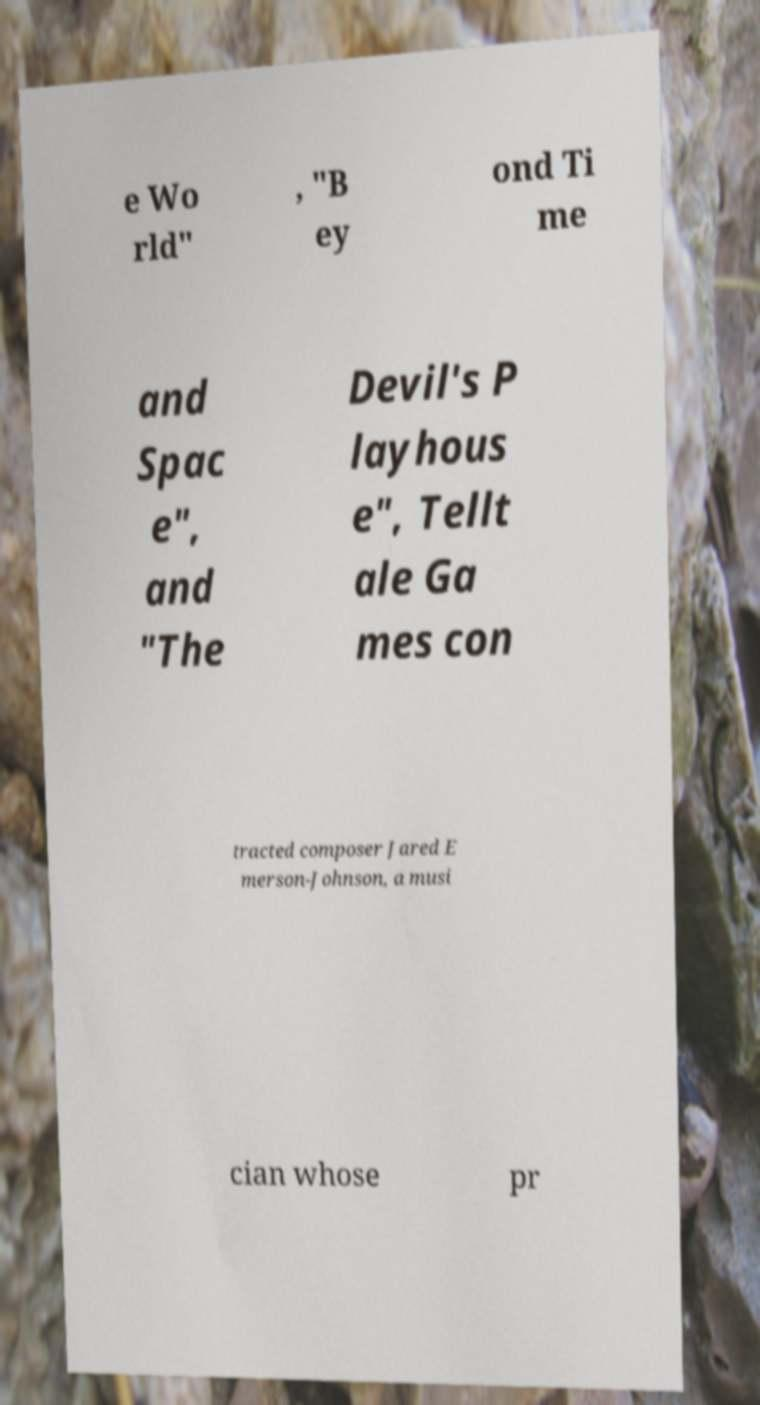Please identify and transcribe the text found in this image. e Wo rld" , "B ey ond Ti me and Spac e", and "The Devil's P layhous e", Tellt ale Ga mes con tracted composer Jared E merson-Johnson, a musi cian whose pr 